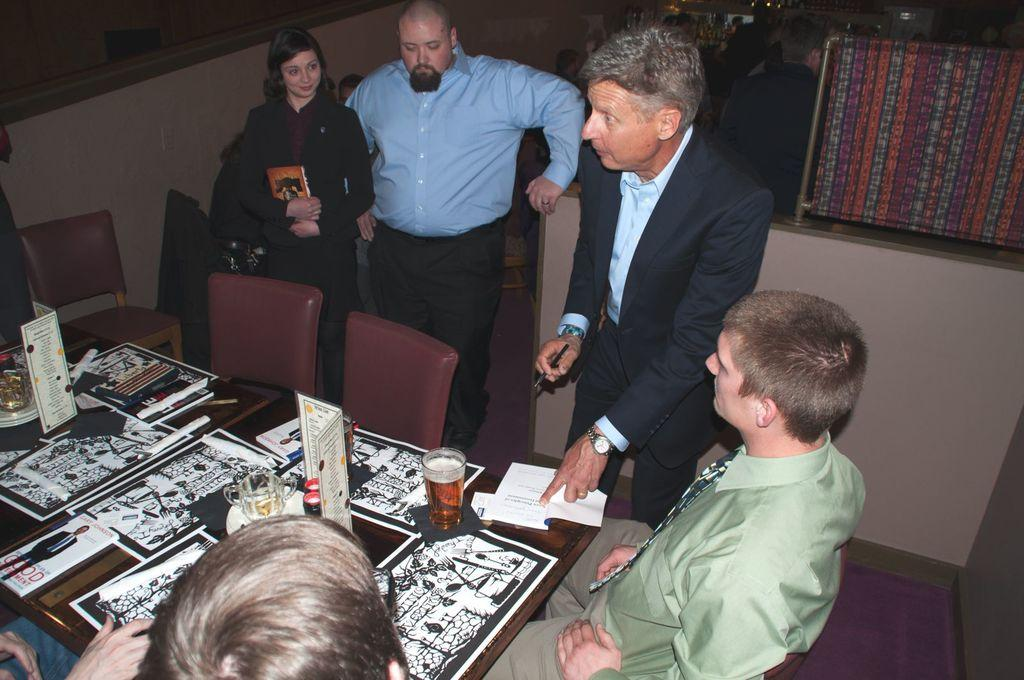How many people are present in the image? There are five people in the image, three standing and two sitting. What are the people doing in the image? The standing people might be observing or interacting with the sitting people. What furniture is visible in the image? There are many chairs and a table in the image. What is placed on the table? A glass of drink is placed on the table. What type of button is being used to control the volleyball game in the image? There is no volleyball game or button present in the image. 